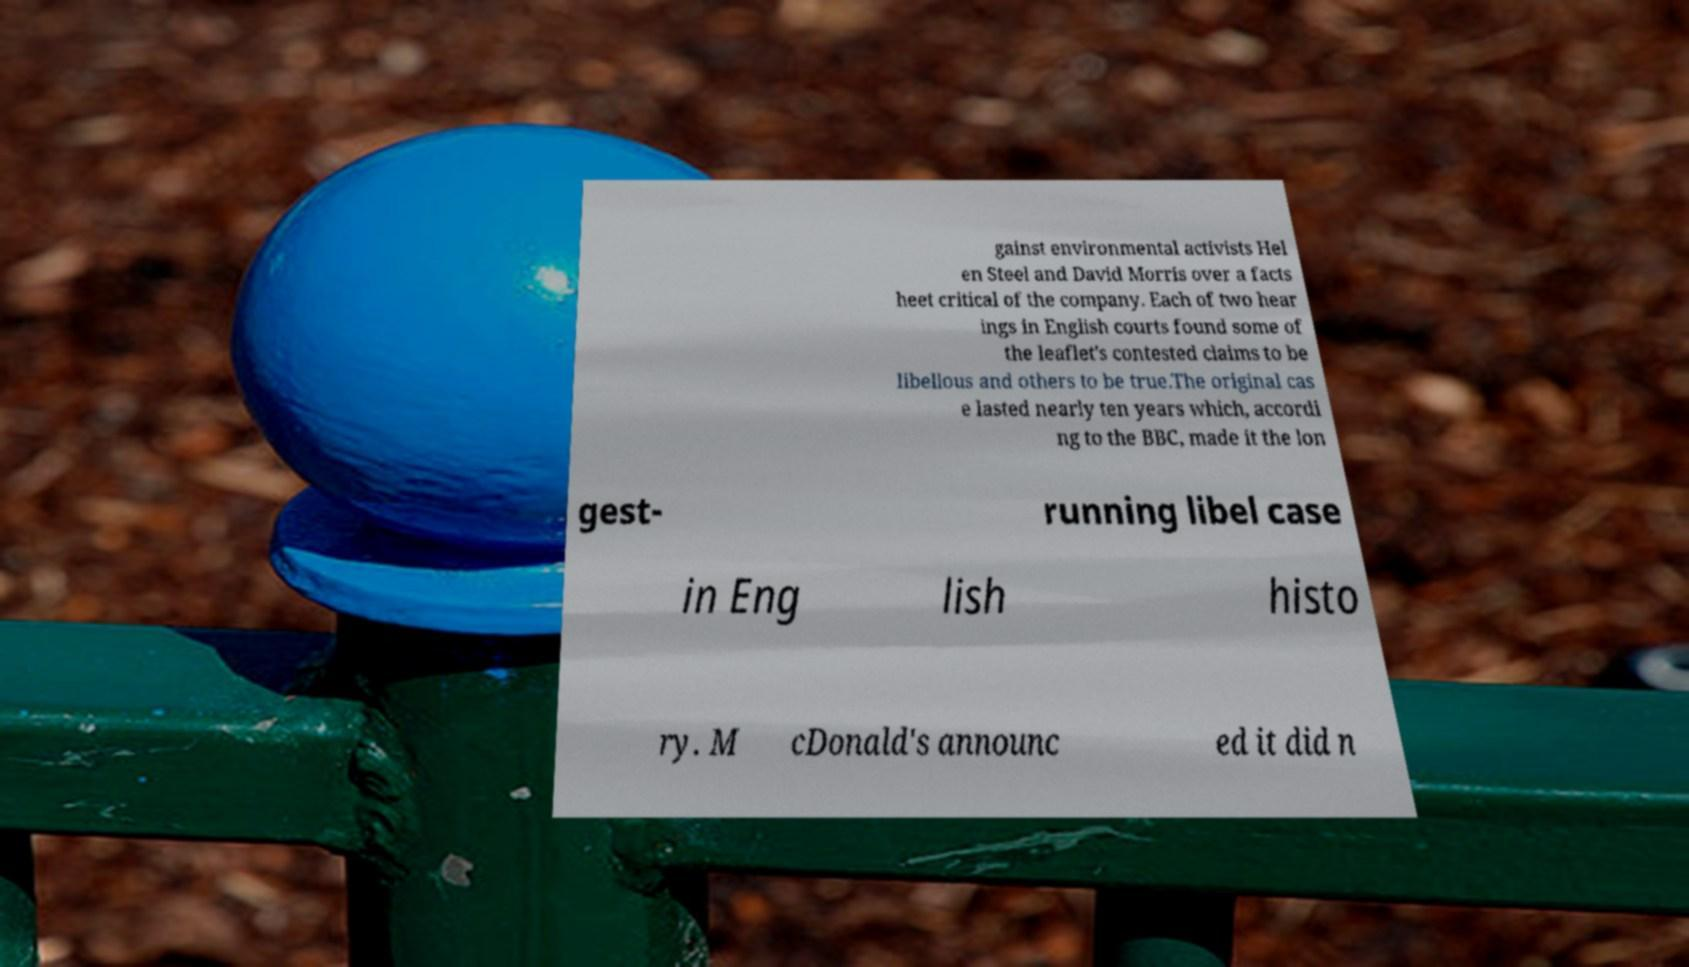Could you extract and type out the text from this image? gainst environmental activists Hel en Steel and David Morris over a facts heet critical of the company. Each of two hear ings in English courts found some of the leaflet's contested claims to be libellous and others to be true.The original cas e lasted nearly ten years which, accordi ng to the BBC, made it the lon gest- running libel case in Eng lish histo ry. M cDonald's announc ed it did n 